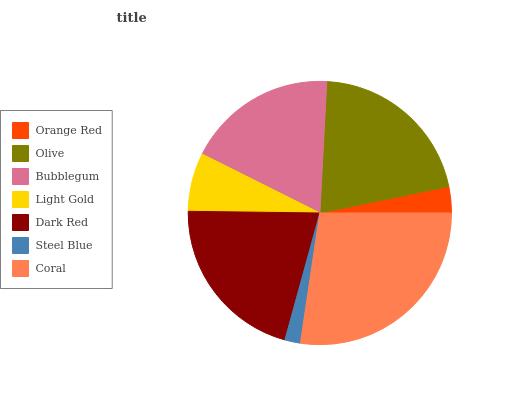Is Steel Blue the minimum?
Answer yes or no. Yes. Is Coral the maximum?
Answer yes or no. Yes. Is Olive the minimum?
Answer yes or no. No. Is Olive the maximum?
Answer yes or no. No. Is Olive greater than Orange Red?
Answer yes or no. Yes. Is Orange Red less than Olive?
Answer yes or no. Yes. Is Orange Red greater than Olive?
Answer yes or no. No. Is Olive less than Orange Red?
Answer yes or no. No. Is Bubblegum the high median?
Answer yes or no. Yes. Is Bubblegum the low median?
Answer yes or no. Yes. Is Coral the high median?
Answer yes or no. No. Is Dark Red the low median?
Answer yes or no. No. 